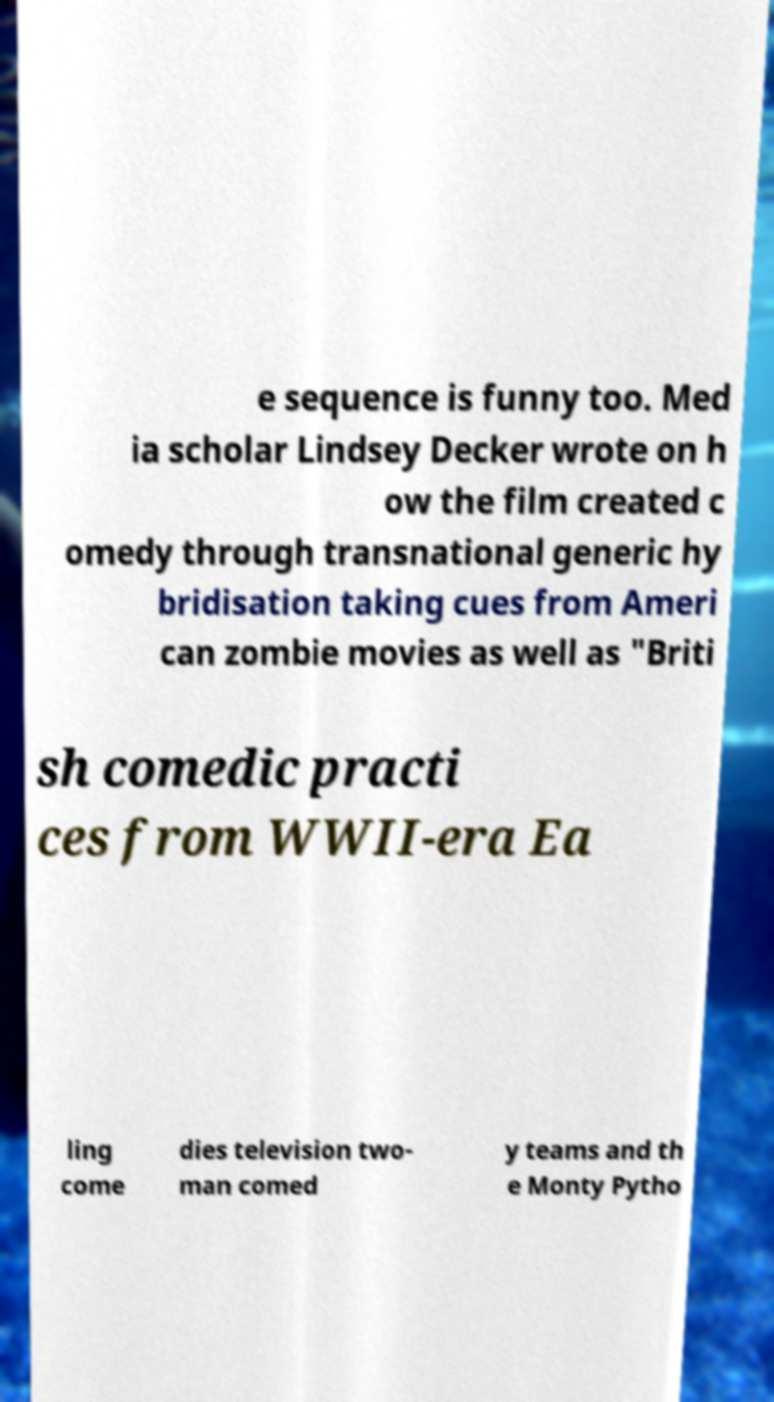What messages or text are displayed in this image? I need them in a readable, typed format. e sequence is funny too. Med ia scholar Lindsey Decker wrote on h ow the film created c omedy through transnational generic hy bridisation taking cues from Ameri can zombie movies as well as "Briti sh comedic practi ces from WWII-era Ea ling come dies television two- man comed y teams and th e Monty Pytho 